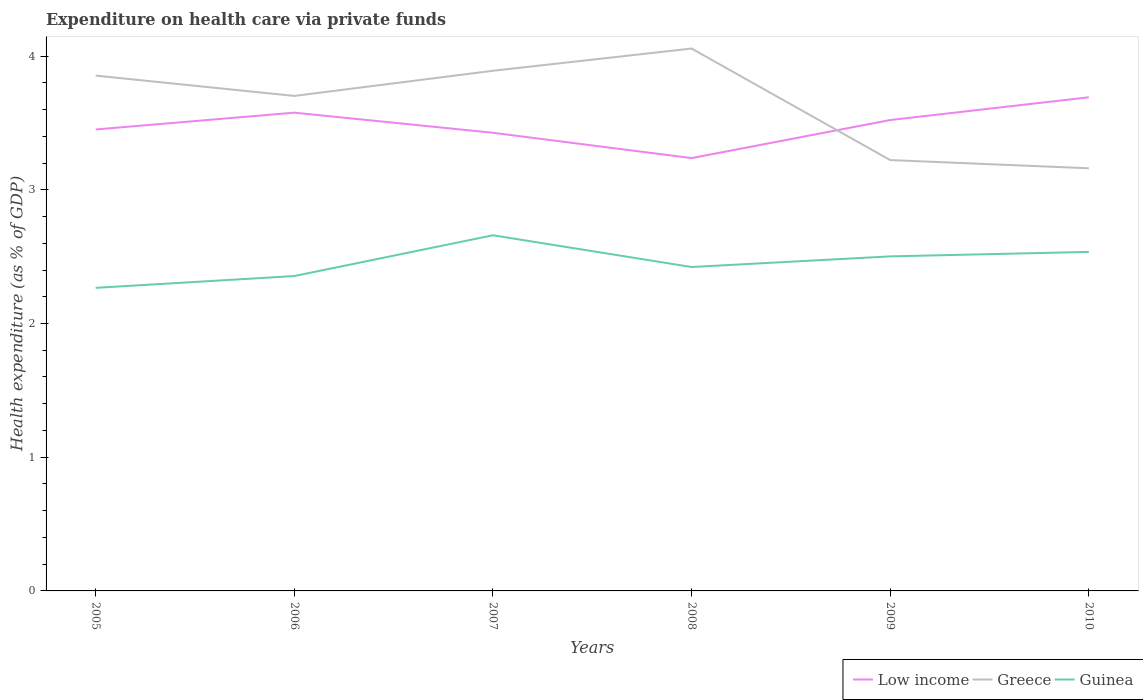Does the line corresponding to Low income intersect with the line corresponding to Guinea?
Offer a terse response. No. Is the number of lines equal to the number of legend labels?
Provide a short and direct response. Yes. Across all years, what is the maximum expenditure made on health care in Low income?
Offer a terse response. 3.24. What is the total expenditure made on health care in Guinea in the graph?
Make the answer very short. -0.27. What is the difference between the highest and the second highest expenditure made on health care in Low income?
Keep it short and to the point. 0.45. What is the difference between the highest and the lowest expenditure made on health care in Low income?
Your answer should be very brief. 3. Is the expenditure made on health care in Guinea strictly greater than the expenditure made on health care in Greece over the years?
Offer a terse response. Yes. How many lines are there?
Your answer should be compact. 3. How many years are there in the graph?
Give a very brief answer. 6. What is the difference between two consecutive major ticks on the Y-axis?
Your response must be concise. 1. Are the values on the major ticks of Y-axis written in scientific E-notation?
Provide a succinct answer. No. Does the graph contain grids?
Your answer should be compact. No. How many legend labels are there?
Your answer should be very brief. 3. What is the title of the graph?
Make the answer very short. Expenditure on health care via private funds. Does "Malawi" appear as one of the legend labels in the graph?
Your response must be concise. No. What is the label or title of the X-axis?
Your answer should be very brief. Years. What is the label or title of the Y-axis?
Keep it short and to the point. Health expenditure (as % of GDP). What is the Health expenditure (as % of GDP) in Low income in 2005?
Keep it short and to the point. 3.45. What is the Health expenditure (as % of GDP) in Greece in 2005?
Your response must be concise. 3.85. What is the Health expenditure (as % of GDP) of Guinea in 2005?
Ensure brevity in your answer.  2.27. What is the Health expenditure (as % of GDP) in Low income in 2006?
Provide a succinct answer. 3.58. What is the Health expenditure (as % of GDP) in Greece in 2006?
Your answer should be very brief. 3.7. What is the Health expenditure (as % of GDP) in Guinea in 2006?
Provide a short and direct response. 2.35. What is the Health expenditure (as % of GDP) in Low income in 2007?
Make the answer very short. 3.43. What is the Health expenditure (as % of GDP) of Greece in 2007?
Provide a short and direct response. 3.89. What is the Health expenditure (as % of GDP) in Guinea in 2007?
Ensure brevity in your answer.  2.66. What is the Health expenditure (as % of GDP) of Low income in 2008?
Your answer should be very brief. 3.24. What is the Health expenditure (as % of GDP) of Greece in 2008?
Offer a terse response. 4.06. What is the Health expenditure (as % of GDP) of Guinea in 2008?
Your answer should be very brief. 2.42. What is the Health expenditure (as % of GDP) of Low income in 2009?
Offer a terse response. 3.52. What is the Health expenditure (as % of GDP) in Greece in 2009?
Provide a succinct answer. 3.22. What is the Health expenditure (as % of GDP) in Guinea in 2009?
Provide a short and direct response. 2.5. What is the Health expenditure (as % of GDP) in Low income in 2010?
Keep it short and to the point. 3.69. What is the Health expenditure (as % of GDP) in Greece in 2010?
Provide a succinct answer. 3.16. What is the Health expenditure (as % of GDP) of Guinea in 2010?
Make the answer very short. 2.54. Across all years, what is the maximum Health expenditure (as % of GDP) of Low income?
Your response must be concise. 3.69. Across all years, what is the maximum Health expenditure (as % of GDP) in Greece?
Your answer should be compact. 4.06. Across all years, what is the maximum Health expenditure (as % of GDP) in Guinea?
Provide a short and direct response. 2.66. Across all years, what is the minimum Health expenditure (as % of GDP) in Low income?
Provide a short and direct response. 3.24. Across all years, what is the minimum Health expenditure (as % of GDP) of Greece?
Keep it short and to the point. 3.16. Across all years, what is the minimum Health expenditure (as % of GDP) of Guinea?
Ensure brevity in your answer.  2.27. What is the total Health expenditure (as % of GDP) of Low income in the graph?
Provide a succinct answer. 20.9. What is the total Health expenditure (as % of GDP) in Greece in the graph?
Keep it short and to the point. 21.89. What is the total Health expenditure (as % of GDP) of Guinea in the graph?
Keep it short and to the point. 14.74. What is the difference between the Health expenditure (as % of GDP) in Low income in 2005 and that in 2006?
Offer a terse response. -0.13. What is the difference between the Health expenditure (as % of GDP) in Greece in 2005 and that in 2006?
Keep it short and to the point. 0.15. What is the difference between the Health expenditure (as % of GDP) of Guinea in 2005 and that in 2006?
Make the answer very short. -0.09. What is the difference between the Health expenditure (as % of GDP) in Low income in 2005 and that in 2007?
Provide a succinct answer. 0.02. What is the difference between the Health expenditure (as % of GDP) of Greece in 2005 and that in 2007?
Offer a very short reply. -0.04. What is the difference between the Health expenditure (as % of GDP) in Guinea in 2005 and that in 2007?
Give a very brief answer. -0.39. What is the difference between the Health expenditure (as % of GDP) of Low income in 2005 and that in 2008?
Make the answer very short. 0.21. What is the difference between the Health expenditure (as % of GDP) in Greece in 2005 and that in 2008?
Provide a succinct answer. -0.2. What is the difference between the Health expenditure (as % of GDP) of Guinea in 2005 and that in 2008?
Offer a terse response. -0.16. What is the difference between the Health expenditure (as % of GDP) in Low income in 2005 and that in 2009?
Keep it short and to the point. -0.07. What is the difference between the Health expenditure (as % of GDP) of Greece in 2005 and that in 2009?
Your response must be concise. 0.63. What is the difference between the Health expenditure (as % of GDP) in Guinea in 2005 and that in 2009?
Ensure brevity in your answer.  -0.24. What is the difference between the Health expenditure (as % of GDP) of Low income in 2005 and that in 2010?
Provide a succinct answer. -0.24. What is the difference between the Health expenditure (as % of GDP) in Greece in 2005 and that in 2010?
Give a very brief answer. 0.69. What is the difference between the Health expenditure (as % of GDP) of Guinea in 2005 and that in 2010?
Provide a succinct answer. -0.27. What is the difference between the Health expenditure (as % of GDP) in Low income in 2006 and that in 2007?
Your response must be concise. 0.15. What is the difference between the Health expenditure (as % of GDP) of Greece in 2006 and that in 2007?
Your response must be concise. -0.19. What is the difference between the Health expenditure (as % of GDP) of Guinea in 2006 and that in 2007?
Give a very brief answer. -0.3. What is the difference between the Health expenditure (as % of GDP) of Low income in 2006 and that in 2008?
Keep it short and to the point. 0.34. What is the difference between the Health expenditure (as % of GDP) in Greece in 2006 and that in 2008?
Your answer should be compact. -0.35. What is the difference between the Health expenditure (as % of GDP) of Guinea in 2006 and that in 2008?
Keep it short and to the point. -0.07. What is the difference between the Health expenditure (as % of GDP) in Low income in 2006 and that in 2009?
Your answer should be very brief. 0.06. What is the difference between the Health expenditure (as % of GDP) of Greece in 2006 and that in 2009?
Keep it short and to the point. 0.48. What is the difference between the Health expenditure (as % of GDP) of Guinea in 2006 and that in 2009?
Make the answer very short. -0.15. What is the difference between the Health expenditure (as % of GDP) of Low income in 2006 and that in 2010?
Offer a very short reply. -0.11. What is the difference between the Health expenditure (as % of GDP) in Greece in 2006 and that in 2010?
Ensure brevity in your answer.  0.54. What is the difference between the Health expenditure (as % of GDP) of Guinea in 2006 and that in 2010?
Offer a terse response. -0.18. What is the difference between the Health expenditure (as % of GDP) in Low income in 2007 and that in 2008?
Your answer should be compact. 0.19. What is the difference between the Health expenditure (as % of GDP) in Greece in 2007 and that in 2008?
Your answer should be very brief. -0.17. What is the difference between the Health expenditure (as % of GDP) in Guinea in 2007 and that in 2008?
Make the answer very short. 0.24. What is the difference between the Health expenditure (as % of GDP) in Low income in 2007 and that in 2009?
Provide a short and direct response. -0.1. What is the difference between the Health expenditure (as % of GDP) in Greece in 2007 and that in 2009?
Provide a short and direct response. 0.67. What is the difference between the Health expenditure (as % of GDP) in Guinea in 2007 and that in 2009?
Ensure brevity in your answer.  0.16. What is the difference between the Health expenditure (as % of GDP) of Low income in 2007 and that in 2010?
Provide a short and direct response. -0.27. What is the difference between the Health expenditure (as % of GDP) in Greece in 2007 and that in 2010?
Keep it short and to the point. 0.73. What is the difference between the Health expenditure (as % of GDP) of Guinea in 2007 and that in 2010?
Offer a terse response. 0.12. What is the difference between the Health expenditure (as % of GDP) of Low income in 2008 and that in 2009?
Offer a very short reply. -0.28. What is the difference between the Health expenditure (as % of GDP) in Greece in 2008 and that in 2009?
Keep it short and to the point. 0.83. What is the difference between the Health expenditure (as % of GDP) in Guinea in 2008 and that in 2009?
Offer a terse response. -0.08. What is the difference between the Health expenditure (as % of GDP) of Low income in 2008 and that in 2010?
Your response must be concise. -0.45. What is the difference between the Health expenditure (as % of GDP) of Greece in 2008 and that in 2010?
Your answer should be very brief. 0.9. What is the difference between the Health expenditure (as % of GDP) in Guinea in 2008 and that in 2010?
Provide a succinct answer. -0.11. What is the difference between the Health expenditure (as % of GDP) in Low income in 2009 and that in 2010?
Your answer should be very brief. -0.17. What is the difference between the Health expenditure (as % of GDP) in Greece in 2009 and that in 2010?
Your answer should be very brief. 0.06. What is the difference between the Health expenditure (as % of GDP) in Guinea in 2009 and that in 2010?
Offer a terse response. -0.03. What is the difference between the Health expenditure (as % of GDP) of Low income in 2005 and the Health expenditure (as % of GDP) of Greece in 2006?
Offer a terse response. -0.25. What is the difference between the Health expenditure (as % of GDP) of Low income in 2005 and the Health expenditure (as % of GDP) of Guinea in 2006?
Make the answer very short. 1.1. What is the difference between the Health expenditure (as % of GDP) in Greece in 2005 and the Health expenditure (as % of GDP) in Guinea in 2006?
Your answer should be compact. 1.5. What is the difference between the Health expenditure (as % of GDP) of Low income in 2005 and the Health expenditure (as % of GDP) of Greece in 2007?
Provide a short and direct response. -0.44. What is the difference between the Health expenditure (as % of GDP) in Low income in 2005 and the Health expenditure (as % of GDP) in Guinea in 2007?
Provide a short and direct response. 0.79. What is the difference between the Health expenditure (as % of GDP) in Greece in 2005 and the Health expenditure (as % of GDP) in Guinea in 2007?
Offer a very short reply. 1.19. What is the difference between the Health expenditure (as % of GDP) of Low income in 2005 and the Health expenditure (as % of GDP) of Greece in 2008?
Ensure brevity in your answer.  -0.61. What is the difference between the Health expenditure (as % of GDP) of Low income in 2005 and the Health expenditure (as % of GDP) of Guinea in 2008?
Ensure brevity in your answer.  1.03. What is the difference between the Health expenditure (as % of GDP) of Greece in 2005 and the Health expenditure (as % of GDP) of Guinea in 2008?
Provide a short and direct response. 1.43. What is the difference between the Health expenditure (as % of GDP) in Low income in 2005 and the Health expenditure (as % of GDP) in Greece in 2009?
Provide a succinct answer. 0.23. What is the difference between the Health expenditure (as % of GDP) of Low income in 2005 and the Health expenditure (as % of GDP) of Guinea in 2009?
Your answer should be very brief. 0.95. What is the difference between the Health expenditure (as % of GDP) of Greece in 2005 and the Health expenditure (as % of GDP) of Guinea in 2009?
Give a very brief answer. 1.35. What is the difference between the Health expenditure (as % of GDP) in Low income in 2005 and the Health expenditure (as % of GDP) in Greece in 2010?
Ensure brevity in your answer.  0.29. What is the difference between the Health expenditure (as % of GDP) in Low income in 2005 and the Health expenditure (as % of GDP) in Guinea in 2010?
Keep it short and to the point. 0.92. What is the difference between the Health expenditure (as % of GDP) in Greece in 2005 and the Health expenditure (as % of GDP) in Guinea in 2010?
Your response must be concise. 1.32. What is the difference between the Health expenditure (as % of GDP) of Low income in 2006 and the Health expenditure (as % of GDP) of Greece in 2007?
Offer a terse response. -0.31. What is the difference between the Health expenditure (as % of GDP) in Low income in 2006 and the Health expenditure (as % of GDP) in Guinea in 2007?
Keep it short and to the point. 0.92. What is the difference between the Health expenditure (as % of GDP) in Greece in 2006 and the Health expenditure (as % of GDP) in Guinea in 2007?
Offer a terse response. 1.04. What is the difference between the Health expenditure (as % of GDP) of Low income in 2006 and the Health expenditure (as % of GDP) of Greece in 2008?
Offer a very short reply. -0.48. What is the difference between the Health expenditure (as % of GDP) of Low income in 2006 and the Health expenditure (as % of GDP) of Guinea in 2008?
Your response must be concise. 1.15. What is the difference between the Health expenditure (as % of GDP) in Greece in 2006 and the Health expenditure (as % of GDP) in Guinea in 2008?
Provide a short and direct response. 1.28. What is the difference between the Health expenditure (as % of GDP) in Low income in 2006 and the Health expenditure (as % of GDP) in Greece in 2009?
Ensure brevity in your answer.  0.35. What is the difference between the Health expenditure (as % of GDP) in Low income in 2006 and the Health expenditure (as % of GDP) in Guinea in 2009?
Offer a terse response. 1.07. What is the difference between the Health expenditure (as % of GDP) of Greece in 2006 and the Health expenditure (as % of GDP) of Guinea in 2009?
Provide a short and direct response. 1.2. What is the difference between the Health expenditure (as % of GDP) in Low income in 2006 and the Health expenditure (as % of GDP) in Greece in 2010?
Provide a succinct answer. 0.42. What is the difference between the Health expenditure (as % of GDP) of Low income in 2006 and the Health expenditure (as % of GDP) of Guinea in 2010?
Keep it short and to the point. 1.04. What is the difference between the Health expenditure (as % of GDP) of Greece in 2006 and the Health expenditure (as % of GDP) of Guinea in 2010?
Your response must be concise. 1.17. What is the difference between the Health expenditure (as % of GDP) in Low income in 2007 and the Health expenditure (as % of GDP) in Greece in 2008?
Your response must be concise. -0.63. What is the difference between the Health expenditure (as % of GDP) of Low income in 2007 and the Health expenditure (as % of GDP) of Guinea in 2008?
Ensure brevity in your answer.  1. What is the difference between the Health expenditure (as % of GDP) of Greece in 2007 and the Health expenditure (as % of GDP) of Guinea in 2008?
Make the answer very short. 1.47. What is the difference between the Health expenditure (as % of GDP) of Low income in 2007 and the Health expenditure (as % of GDP) of Greece in 2009?
Your answer should be compact. 0.2. What is the difference between the Health expenditure (as % of GDP) in Low income in 2007 and the Health expenditure (as % of GDP) in Guinea in 2009?
Provide a succinct answer. 0.92. What is the difference between the Health expenditure (as % of GDP) in Greece in 2007 and the Health expenditure (as % of GDP) in Guinea in 2009?
Make the answer very short. 1.39. What is the difference between the Health expenditure (as % of GDP) of Low income in 2007 and the Health expenditure (as % of GDP) of Greece in 2010?
Your answer should be compact. 0.27. What is the difference between the Health expenditure (as % of GDP) in Low income in 2007 and the Health expenditure (as % of GDP) in Guinea in 2010?
Your answer should be compact. 0.89. What is the difference between the Health expenditure (as % of GDP) in Greece in 2007 and the Health expenditure (as % of GDP) in Guinea in 2010?
Provide a short and direct response. 1.35. What is the difference between the Health expenditure (as % of GDP) in Low income in 2008 and the Health expenditure (as % of GDP) in Greece in 2009?
Provide a short and direct response. 0.01. What is the difference between the Health expenditure (as % of GDP) in Low income in 2008 and the Health expenditure (as % of GDP) in Guinea in 2009?
Keep it short and to the point. 0.73. What is the difference between the Health expenditure (as % of GDP) of Greece in 2008 and the Health expenditure (as % of GDP) of Guinea in 2009?
Ensure brevity in your answer.  1.55. What is the difference between the Health expenditure (as % of GDP) in Low income in 2008 and the Health expenditure (as % of GDP) in Greece in 2010?
Your response must be concise. 0.08. What is the difference between the Health expenditure (as % of GDP) in Low income in 2008 and the Health expenditure (as % of GDP) in Guinea in 2010?
Make the answer very short. 0.7. What is the difference between the Health expenditure (as % of GDP) in Greece in 2008 and the Health expenditure (as % of GDP) in Guinea in 2010?
Your answer should be very brief. 1.52. What is the difference between the Health expenditure (as % of GDP) in Low income in 2009 and the Health expenditure (as % of GDP) in Greece in 2010?
Your response must be concise. 0.36. What is the difference between the Health expenditure (as % of GDP) of Low income in 2009 and the Health expenditure (as % of GDP) of Guinea in 2010?
Your response must be concise. 0.99. What is the difference between the Health expenditure (as % of GDP) in Greece in 2009 and the Health expenditure (as % of GDP) in Guinea in 2010?
Offer a terse response. 0.69. What is the average Health expenditure (as % of GDP) in Low income per year?
Your answer should be compact. 3.48. What is the average Health expenditure (as % of GDP) in Greece per year?
Your answer should be very brief. 3.65. What is the average Health expenditure (as % of GDP) of Guinea per year?
Ensure brevity in your answer.  2.46. In the year 2005, what is the difference between the Health expenditure (as % of GDP) in Low income and Health expenditure (as % of GDP) in Greece?
Your answer should be very brief. -0.4. In the year 2005, what is the difference between the Health expenditure (as % of GDP) in Low income and Health expenditure (as % of GDP) in Guinea?
Give a very brief answer. 1.18. In the year 2005, what is the difference between the Health expenditure (as % of GDP) in Greece and Health expenditure (as % of GDP) in Guinea?
Your answer should be very brief. 1.59. In the year 2006, what is the difference between the Health expenditure (as % of GDP) in Low income and Health expenditure (as % of GDP) in Greece?
Your answer should be very brief. -0.13. In the year 2006, what is the difference between the Health expenditure (as % of GDP) of Low income and Health expenditure (as % of GDP) of Guinea?
Offer a terse response. 1.22. In the year 2006, what is the difference between the Health expenditure (as % of GDP) of Greece and Health expenditure (as % of GDP) of Guinea?
Provide a succinct answer. 1.35. In the year 2007, what is the difference between the Health expenditure (as % of GDP) of Low income and Health expenditure (as % of GDP) of Greece?
Ensure brevity in your answer.  -0.46. In the year 2007, what is the difference between the Health expenditure (as % of GDP) in Low income and Health expenditure (as % of GDP) in Guinea?
Ensure brevity in your answer.  0.77. In the year 2007, what is the difference between the Health expenditure (as % of GDP) of Greece and Health expenditure (as % of GDP) of Guinea?
Keep it short and to the point. 1.23. In the year 2008, what is the difference between the Health expenditure (as % of GDP) in Low income and Health expenditure (as % of GDP) in Greece?
Offer a terse response. -0.82. In the year 2008, what is the difference between the Health expenditure (as % of GDP) of Low income and Health expenditure (as % of GDP) of Guinea?
Offer a terse response. 0.81. In the year 2008, what is the difference between the Health expenditure (as % of GDP) of Greece and Health expenditure (as % of GDP) of Guinea?
Offer a terse response. 1.63. In the year 2009, what is the difference between the Health expenditure (as % of GDP) in Low income and Health expenditure (as % of GDP) in Greece?
Your answer should be very brief. 0.3. In the year 2009, what is the difference between the Health expenditure (as % of GDP) of Low income and Health expenditure (as % of GDP) of Guinea?
Provide a succinct answer. 1.02. In the year 2009, what is the difference between the Health expenditure (as % of GDP) of Greece and Health expenditure (as % of GDP) of Guinea?
Offer a terse response. 0.72. In the year 2010, what is the difference between the Health expenditure (as % of GDP) in Low income and Health expenditure (as % of GDP) in Greece?
Offer a terse response. 0.53. In the year 2010, what is the difference between the Health expenditure (as % of GDP) in Low income and Health expenditure (as % of GDP) in Guinea?
Offer a very short reply. 1.16. In the year 2010, what is the difference between the Health expenditure (as % of GDP) in Greece and Health expenditure (as % of GDP) in Guinea?
Keep it short and to the point. 0.63. What is the ratio of the Health expenditure (as % of GDP) of Low income in 2005 to that in 2006?
Make the answer very short. 0.96. What is the ratio of the Health expenditure (as % of GDP) of Greece in 2005 to that in 2006?
Your answer should be very brief. 1.04. What is the ratio of the Health expenditure (as % of GDP) of Guinea in 2005 to that in 2006?
Make the answer very short. 0.96. What is the ratio of the Health expenditure (as % of GDP) of Guinea in 2005 to that in 2007?
Provide a succinct answer. 0.85. What is the ratio of the Health expenditure (as % of GDP) of Low income in 2005 to that in 2008?
Provide a short and direct response. 1.07. What is the ratio of the Health expenditure (as % of GDP) of Greece in 2005 to that in 2008?
Give a very brief answer. 0.95. What is the ratio of the Health expenditure (as % of GDP) of Guinea in 2005 to that in 2008?
Provide a succinct answer. 0.94. What is the ratio of the Health expenditure (as % of GDP) in Low income in 2005 to that in 2009?
Keep it short and to the point. 0.98. What is the ratio of the Health expenditure (as % of GDP) in Greece in 2005 to that in 2009?
Your answer should be very brief. 1.2. What is the ratio of the Health expenditure (as % of GDP) of Guinea in 2005 to that in 2009?
Give a very brief answer. 0.91. What is the ratio of the Health expenditure (as % of GDP) of Low income in 2005 to that in 2010?
Ensure brevity in your answer.  0.93. What is the ratio of the Health expenditure (as % of GDP) of Greece in 2005 to that in 2010?
Provide a short and direct response. 1.22. What is the ratio of the Health expenditure (as % of GDP) in Guinea in 2005 to that in 2010?
Offer a very short reply. 0.89. What is the ratio of the Health expenditure (as % of GDP) in Low income in 2006 to that in 2007?
Ensure brevity in your answer.  1.04. What is the ratio of the Health expenditure (as % of GDP) in Greece in 2006 to that in 2007?
Your answer should be compact. 0.95. What is the ratio of the Health expenditure (as % of GDP) in Guinea in 2006 to that in 2007?
Make the answer very short. 0.89. What is the ratio of the Health expenditure (as % of GDP) of Low income in 2006 to that in 2008?
Your answer should be compact. 1.1. What is the ratio of the Health expenditure (as % of GDP) of Greece in 2006 to that in 2008?
Ensure brevity in your answer.  0.91. What is the ratio of the Health expenditure (as % of GDP) in Guinea in 2006 to that in 2008?
Give a very brief answer. 0.97. What is the ratio of the Health expenditure (as % of GDP) in Low income in 2006 to that in 2009?
Provide a succinct answer. 1.02. What is the ratio of the Health expenditure (as % of GDP) in Greece in 2006 to that in 2009?
Your answer should be compact. 1.15. What is the ratio of the Health expenditure (as % of GDP) in Low income in 2006 to that in 2010?
Your answer should be very brief. 0.97. What is the ratio of the Health expenditure (as % of GDP) in Greece in 2006 to that in 2010?
Make the answer very short. 1.17. What is the ratio of the Health expenditure (as % of GDP) of Guinea in 2006 to that in 2010?
Keep it short and to the point. 0.93. What is the ratio of the Health expenditure (as % of GDP) of Low income in 2007 to that in 2008?
Provide a succinct answer. 1.06. What is the ratio of the Health expenditure (as % of GDP) of Guinea in 2007 to that in 2008?
Keep it short and to the point. 1.1. What is the ratio of the Health expenditure (as % of GDP) in Low income in 2007 to that in 2009?
Provide a succinct answer. 0.97. What is the ratio of the Health expenditure (as % of GDP) in Greece in 2007 to that in 2009?
Provide a succinct answer. 1.21. What is the ratio of the Health expenditure (as % of GDP) of Guinea in 2007 to that in 2009?
Make the answer very short. 1.06. What is the ratio of the Health expenditure (as % of GDP) of Low income in 2007 to that in 2010?
Make the answer very short. 0.93. What is the ratio of the Health expenditure (as % of GDP) in Greece in 2007 to that in 2010?
Your response must be concise. 1.23. What is the ratio of the Health expenditure (as % of GDP) of Guinea in 2007 to that in 2010?
Offer a terse response. 1.05. What is the ratio of the Health expenditure (as % of GDP) of Low income in 2008 to that in 2009?
Provide a short and direct response. 0.92. What is the ratio of the Health expenditure (as % of GDP) of Greece in 2008 to that in 2009?
Your answer should be compact. 1.26. What is the ratio of the Health expenditure (as % of GDP) of Guinea in 2008 to that in 2009?
Offer a terse response. 0.97. What is the ratio of the Health expenditure (as % of GDP) of Low income in 2008 to that in 2010?
Ensure brevity in your answer.  0.88. What is the ratio of the Health expenditure (as % of GDP) of Greece in 2008 to that in 2010?
Your answer should be very brief. 1.28. What is the ratio of the Health expenditure (as % of GDP) of Guinea in 2008 to that in 2010?
Ensure brevity in your answer.  0.96. What is the ratio of the Health expenditure (as % of GDP) of Low income in 2009 to that in 2010?
Provide a succinct answer. 0.95. What is the ratio of the Health expenditure (as % of GDP) of Greece in 2009 to that in 2010?
Make the answer very short. 1.02. What is the difference between the highest and the second highest Health expenditure (as % of GDP) of Low income?
Offer a terse response. 0.11. What is the difference between the highest and the second highest Health expenditure (as % of GDP) of Greece?
Give a very brief answer. 0.17. What is the difference between the highest and the second highest Health expenditure (as % of GDP) of Guinea?
Give a very brief answer. 0.12. What is the difference between the highest and the lowest Health expenditure (as % of GDP) of Low income?
Offer a very short reply. 0.45. What is the difference between the highest and the lowest Health expenditure (as % of GDP) in Greece?
Your response must be concise. 0.9. What is the difference between the highest and the lowest Health expenditure (as % of GDP) in Guinea?
Make the answer very short. 0.39. 